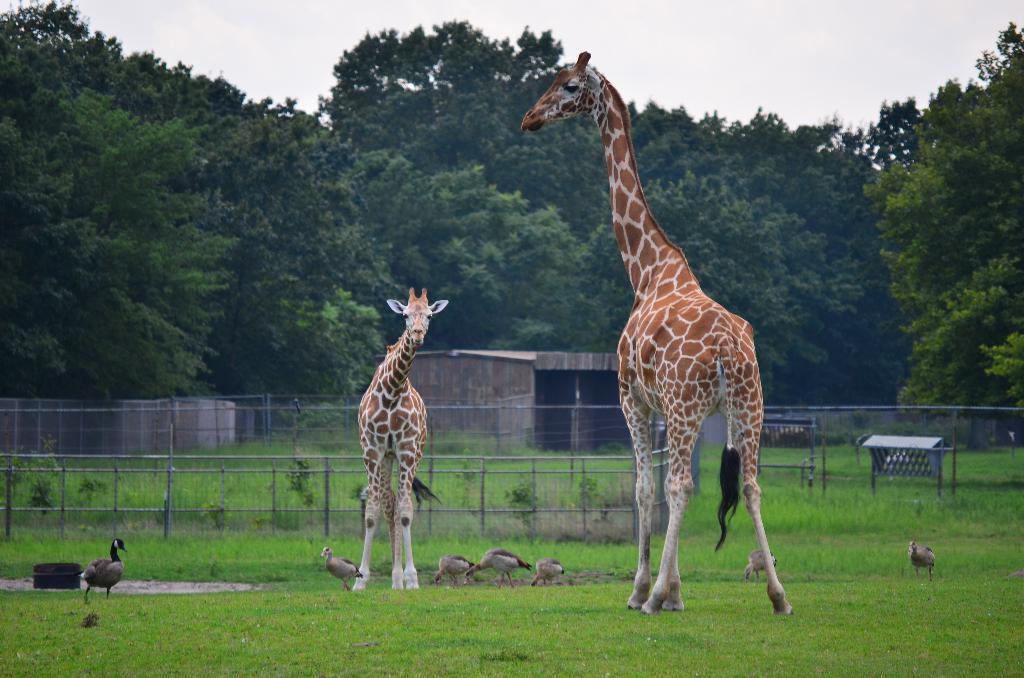In one or two sentences, can you explain what this image depicts? In this image I can see two giraffes standing on the ground and I can see few birds visible on the ground, in the background I can see the sky and trees, on the ground I can see fence and tent house and the wall. 